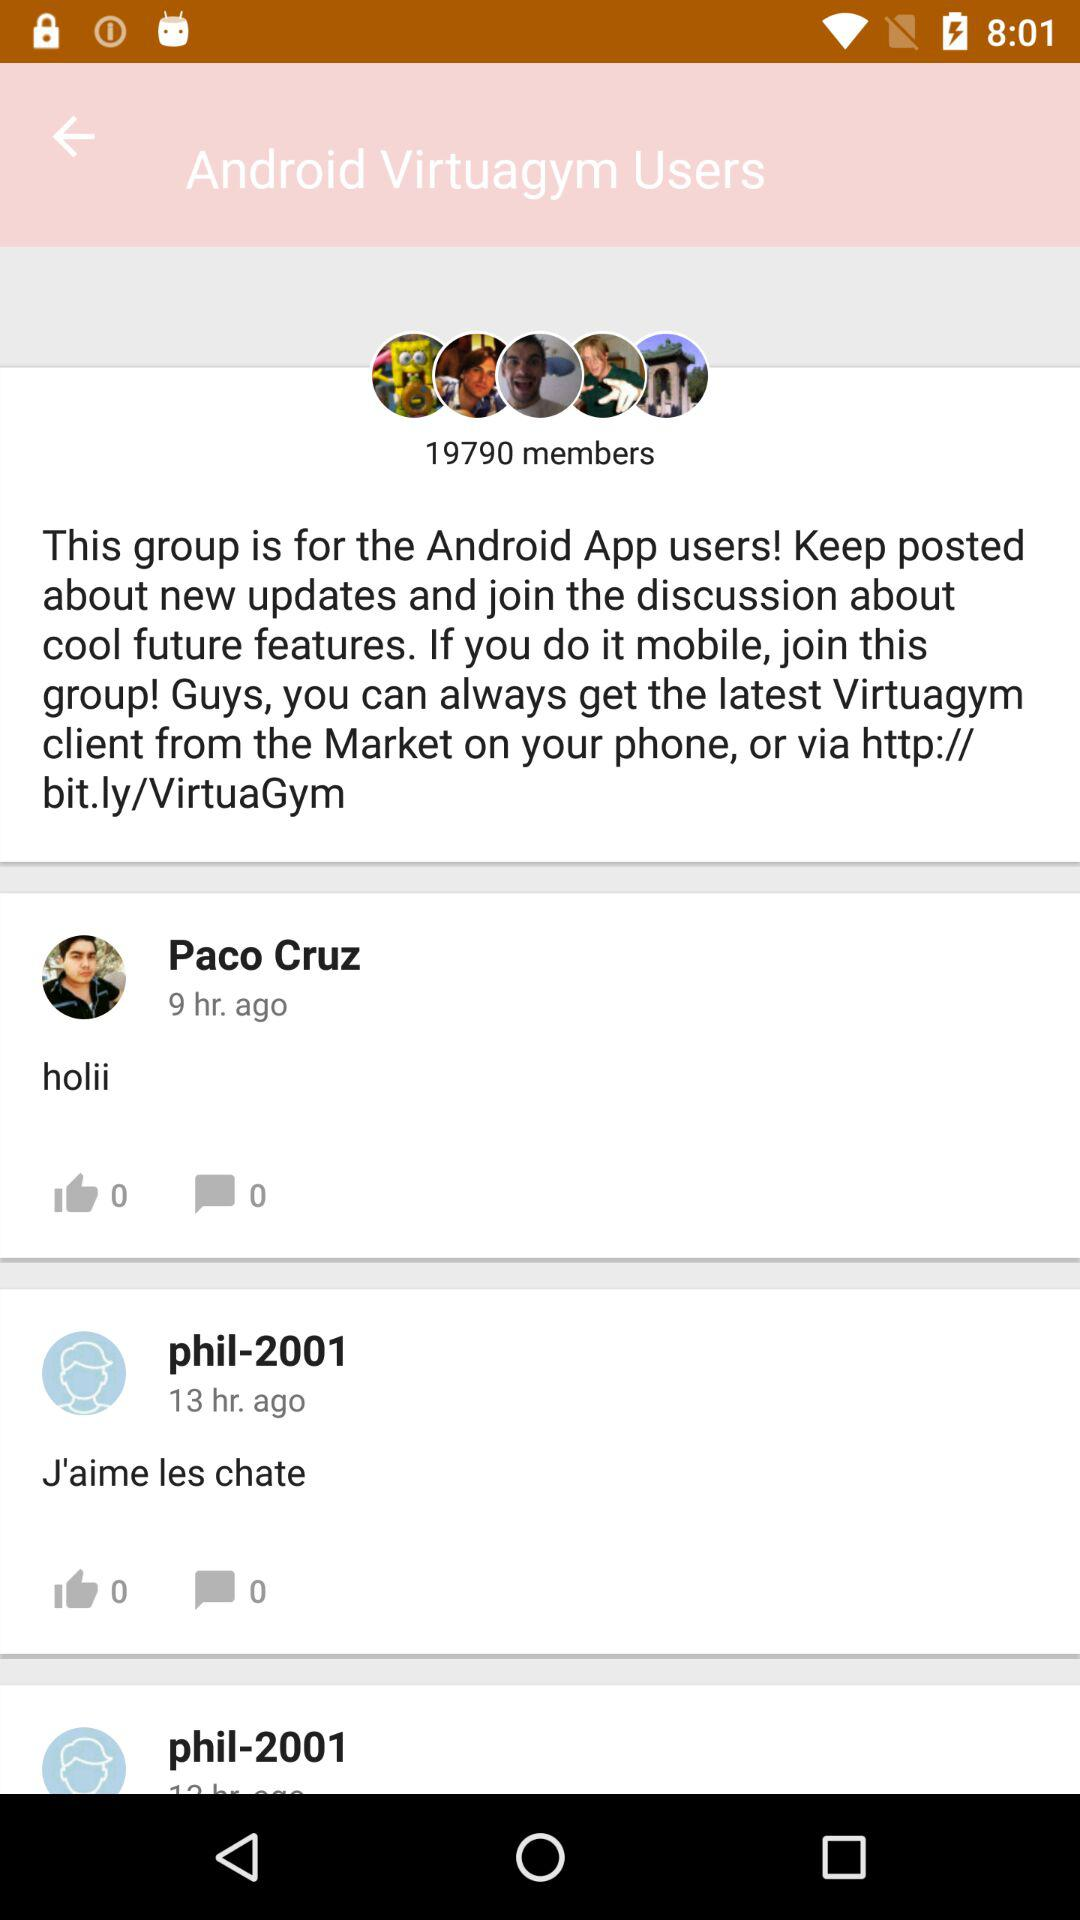How many members are there? There are 19790 members. 